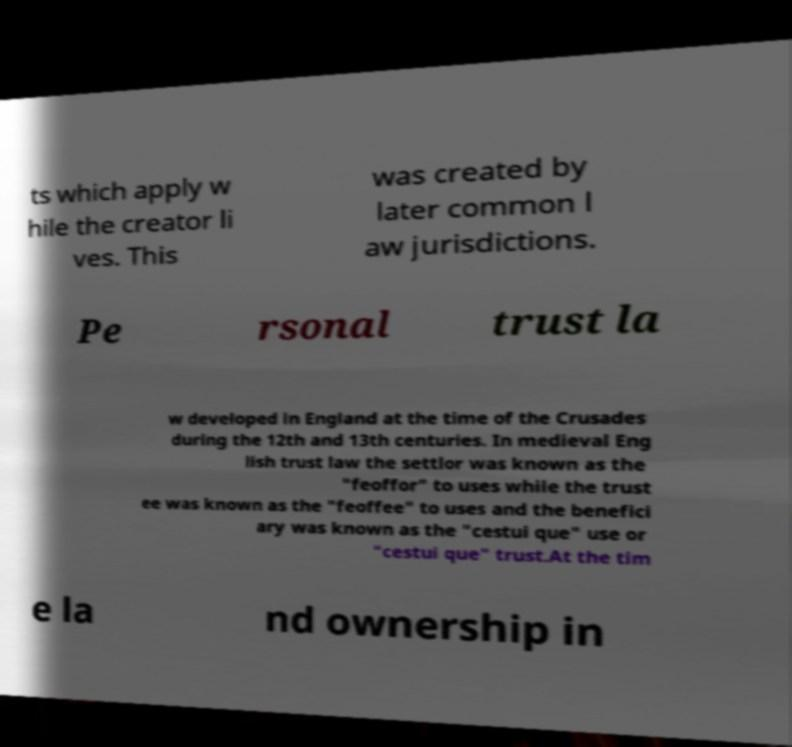Please read and relay the text visible in this image. What does it say? ts which apply w hile the creator li ves. This was created by later common l aw jurisdictions. Pe rsonal trust la w developed in England at the time of the Crusades during the 12th and 13th centuries. In medieval Eng lish trust law the settlor was known as the "feoffor" to uses while the trust ee was known as the "feoffee" to uses and the benefici ary was known as the "cestui que" use or "cestui que" trust.At the tim e la nd ownership in 